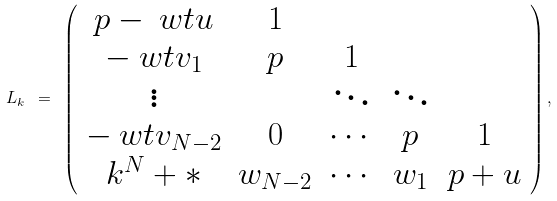Convert formula to latex. <formula><loc_0><loc_0><loc_500><loc_500>L _ { k } \ = \ \left ( \begin{array} { c c c c c } p - \ w t { u } & 1 & & & \\ - \ w t { v } _ { 1 } & p & 1 & & \\ \vdots & & \ddots & \ddots & \\ - \ w t { v } _ { N - 2 } & 0 & \cdots & p & 1 \\ k ^ { N } + \ast & w _ { N - 2 } & \cdots & w _ { 1 } & p + u \\ \end{array} \right ) ,</formula> 